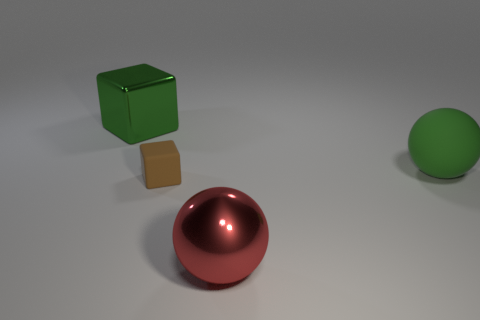Add 4 large red things. How many objects exist? 8 Subtract 2 blocks. How many blocks are left? 0 Subtract all large green things. Subtract all rubber spheres. How many objects are left? 1 Add 3 balls. How many balls are left? 5 Add 3 blocks. How many blocks exist? 5 Subtract 0 brown balls. How many objects are left? 4 Subtract all gray cubes. Subtract all cyan balls. How many cubes are left? 2 Subtract all gray balls. How many brown cubes are left? 1 